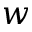Convert formula to latex. <formula><loc_0><loc_0><loc_500><loc_500>w</formula> 